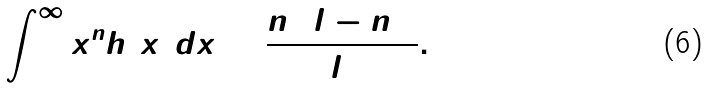Convert formula to latex. <formula><loc_0><loc_0><loc_500><loc_500>\int _ { 0 } ^ { \infty } x ^ { n } h ( x ) d x = \frac { n ! ( l - n ) ! } { l ! } .</formula> 